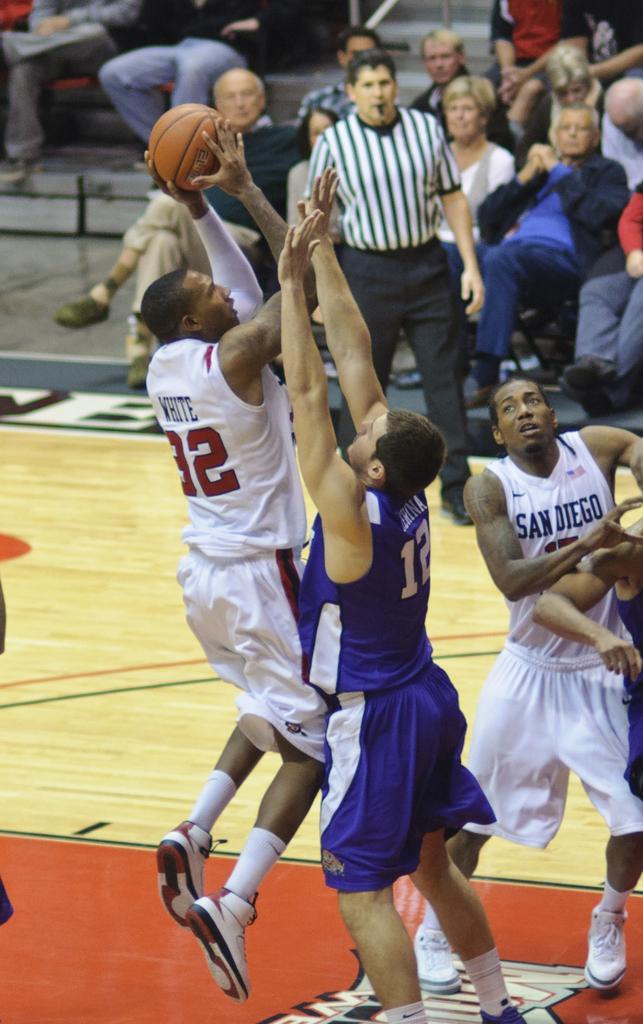In one or two sentences, can you explain what this image depicts? In this image, I can see a group of people playing the basketball game and a person standing. In the background, there are group of people sitting. 